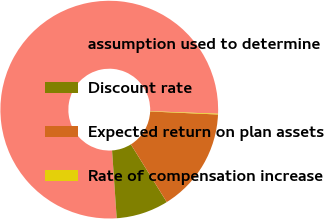Convert chart to OTSL. <chart><loc_0><loc_0><loc_500><loc_500><pie_chart><fcel>assumption used to determine<fcel>Discount rate<fcel>Expected return on plan assets<fcel>Rate of compensation increase<nl><fcel>76.69%<fcel>7.77%<fcel>15.43%<fcel>0.11%<nl></chart> 